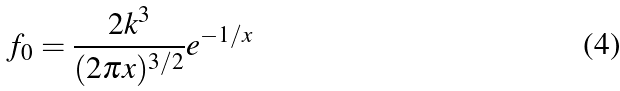Convert formula to latex. <formula><loc_0><loc_0><loc_500><loc_500>f _ { 0 } = \frac { 2 k ^ { 3 } } { ( 2 \pi x ) ^ { 3 / 2 } } e ^ { - 1 / x }</formula> 